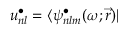<formula> <loc_0><loc_0><loc_500><loc_500>u _ { n l } ^ { \bullet } = \langle \psi _ { n l m } ^ { \bullet } ( \omega ; \vec { r } ) |</formula> 